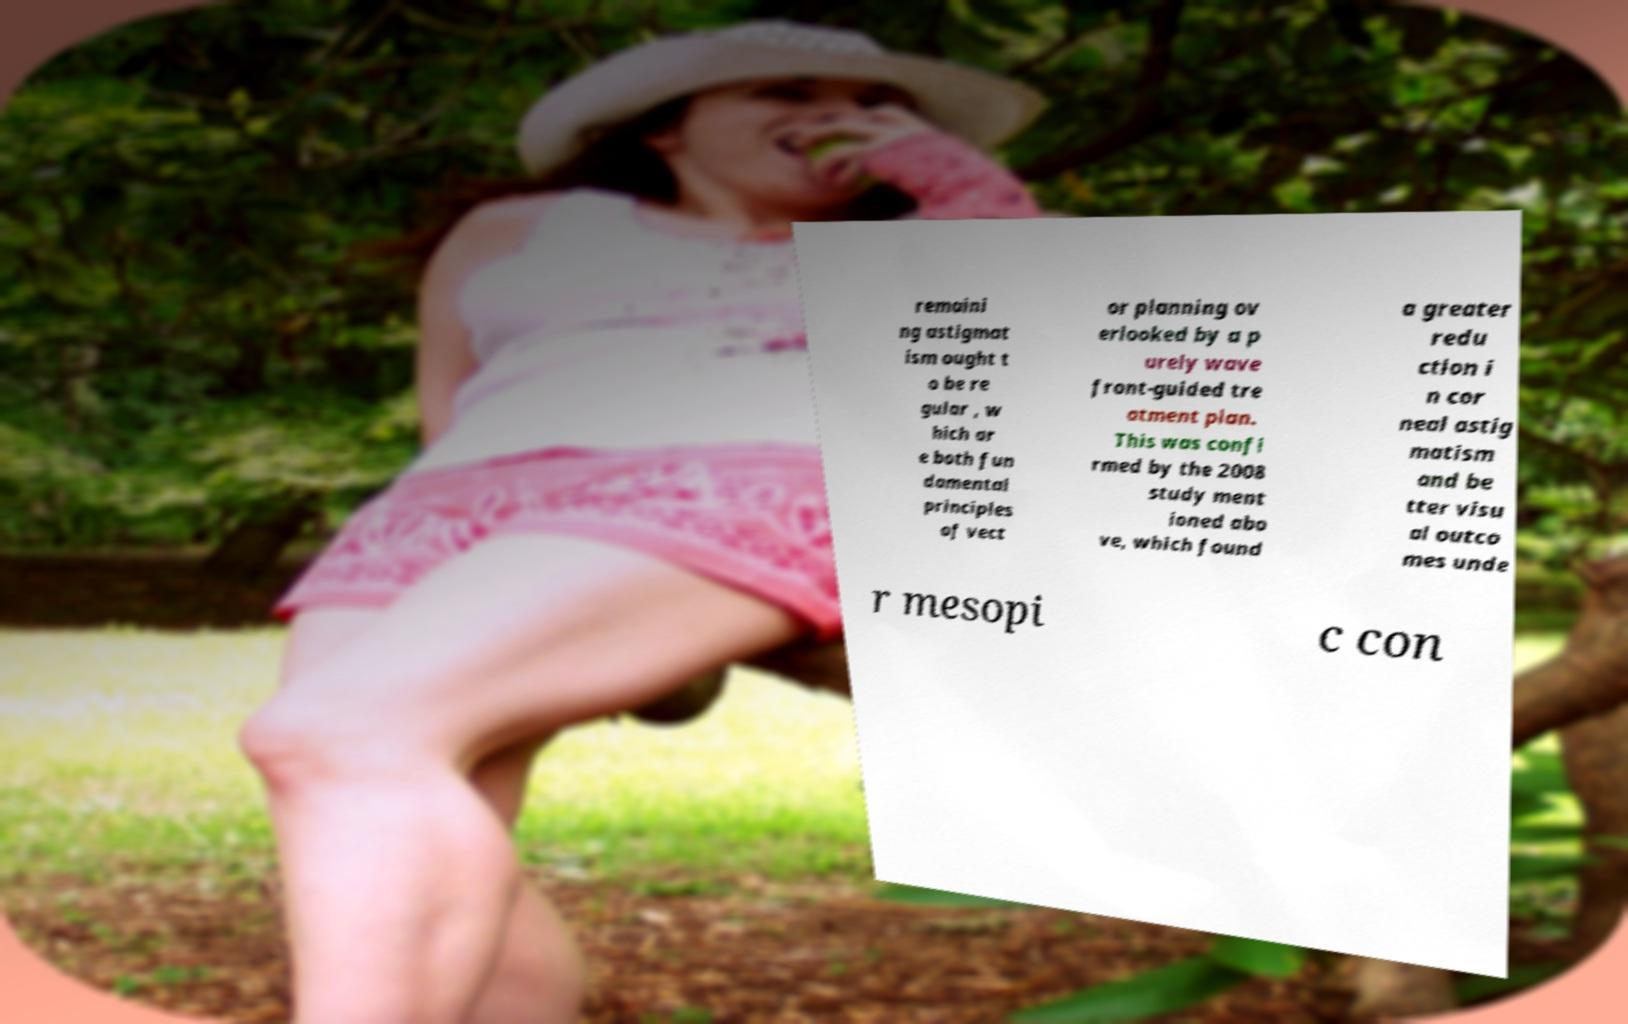Can you read and provide the text displayed in the image?This photo seems to have some interesting text. Can you extract and type it out for me? remaini ng astigmat ism ought t o be re gular , w hich ar e both fun damental principles of vect or planning ov erlooked by a p urely wave front-guided tre atment plan. This was confi rmed by the 2008 study ment ioned abo ve, which found a greater redu ction i n cor neal astig matism and be tter visu al outco mes unde r mesopi c con 